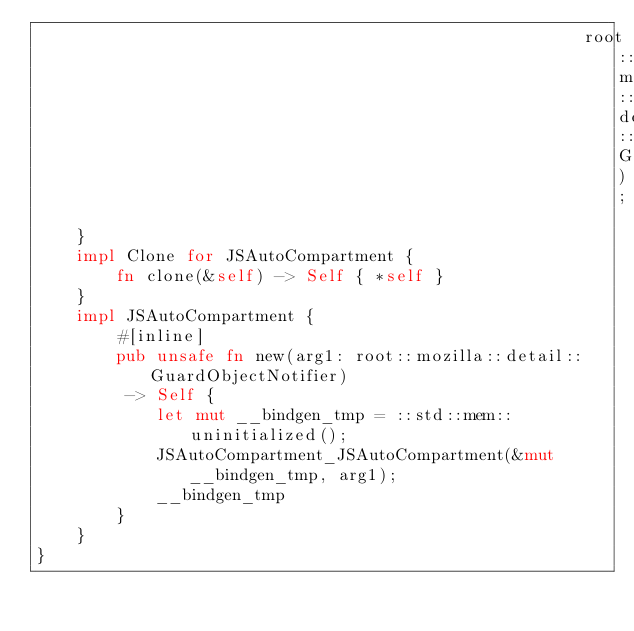<code> <loc_0><loc_0><loc_500><loc_500><_Rust_>                                                       root::mozilla::detail::GuardObjectNotifier);
    }
    impl Clone for JSAutoCompartment {
        fn clone(&self) -> Self { *self }
    }
    impl JSAutoCompartment {
        #[inline]
        pub unsafe fn new(arg1: root::mozilla::detail::GuardObjectNotifier)
         -> Self {
            let mut __bindgen_tmp = ::std::mem::uninitialized();
            JSAutoCompartment_JSAutoCompartment(&mut __bindgen_tmp, arg1);
            __bindgen_tmp
        }
    }
}
</code> 